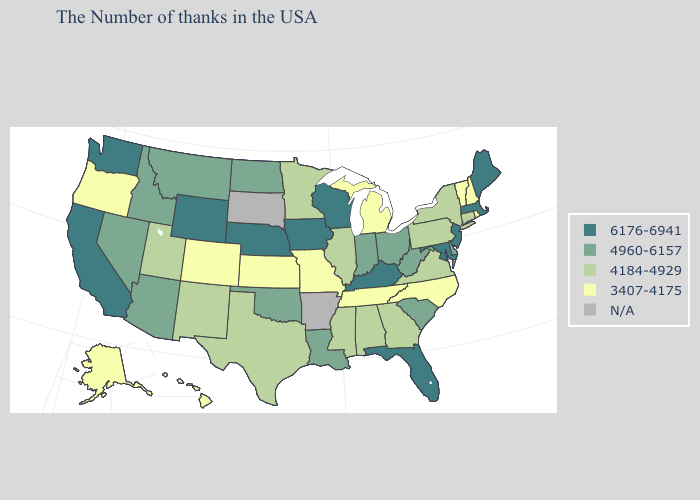What is the lowest value in the USA?
Keep it brief. 3407-4175. What is the value of Tennessee?
Answer briefly. 3407-4175. Name the states that have a value in the range N/A?
Concise answer only. Arkansas, South Dakota. Name the states that have a value in the range 6176-6941?
Concise answer only. Maine, Massachusetts, New Jersey, Maryland, Florida, Kentucky, Wisconsin, Iowa, Nebraska, Wyoming, California, Washington. Name the states that have a value in the range N/A?
Concise answer only. Arkansas, South Dakota. What is the value of Minnesota?
Be succinct. 4184-4929. Which states hav the highest value in the South?
Be succinct. Maryland, Florida, Kentucky. Which states have the lowest value in the West?
Give a very brief answer. Colorado, Oregon, Alaska, Hawaii. Name the states that have a value in the range 6176-6941?
Concise answer only. Maine, Massachusetts, New Jersey, Maryland, Florida, Kentucky, Wisconsin, Iowa, Nebraska, Wyoming, California, Washington. What is the value of Massachusetts?
Concise answer only. 6176-6941. Name the states that have a value in the range 6176-6941?
Quick response, please. Maine, Massachusetts, New Jersey, Maryland, Florida, Kentucky, Wisconsin, Iowa, Nebraska, Wyoming, California, Washington. Does the map have missing data?
Write a very short answer. Yes. Does Washington have the highest value in the USA?
Give a very brief answer. Yes. Which states have the lowest value in the West?
Write a very short answer. Colorado, Oregon, Alaska, Hawaii. What is the highest value in states that border Georgia?
Give a very brief answer. 6176-6941. 